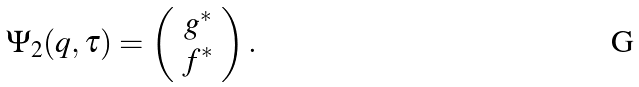Convert formula to latex. <formula><loc_0><loc_0><loc_500><loc_500>\Psi _ { 2 } ( q , \tau ) = \left ( \begin{array} { c } g ^ { * } \\ f ^ { * } \end{array} \right ) .</formula> 